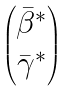<formula> <loc_0><loc_0><loc_500><loc_500>\begin{pmatrix} \bar { \beta } ^ { \ast } \\ \bar { \gamma } ^ { \ast } \end{pmatrix}</formula> 